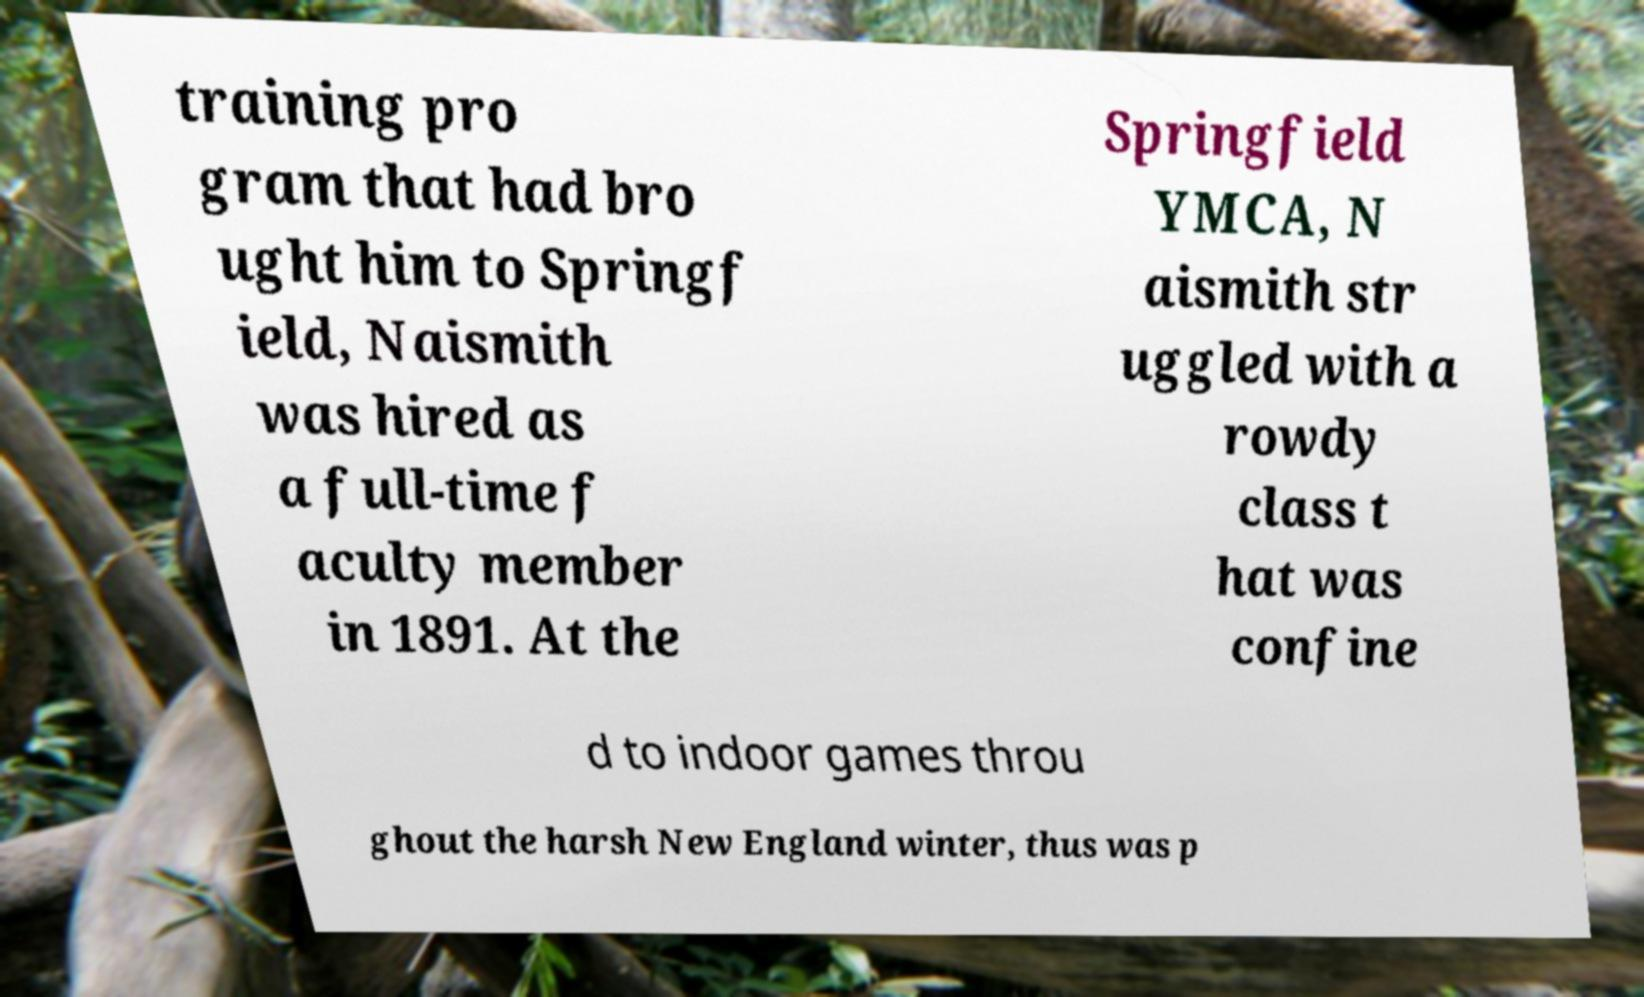I need the written content from this picture converted into text. Can you do that? training pro gram that had bro ught him to Springf ield, Naismith was hired as a full-time f aculty member in 1891. At the Springfield YMCA, N aismith str uggled with a rowdy class t hat was confine d to indoor games throu ghout the harsh New England winter, thus was p 